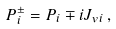Convert formula to latex. <formula><loc_0><loc_0><loc_500><loc_500>P _ { i } ^ { \pm } = P _ { i } \mp i J _ { v i } \, ,</formula> 